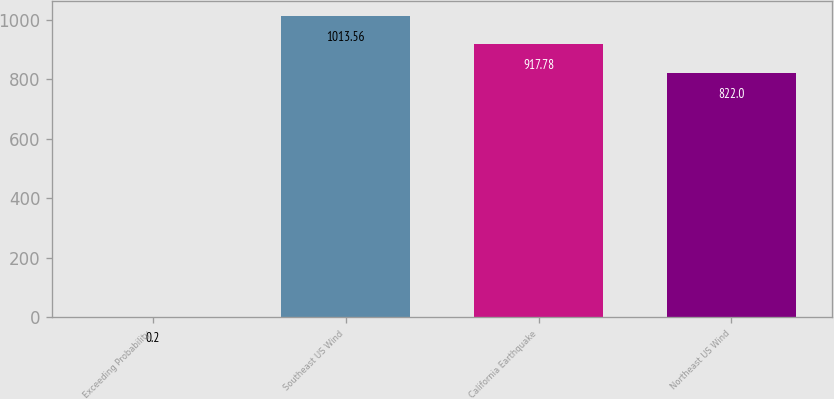<chart> <loc_0><loc_0><loc_500><loc_500><bar_chart><fcel>Exceeding Probability<fcel>Southeast US Wind<fcel>California Earthquake<fcel>Northeast US Wind<nl><fcel>0.2<fcel>1013.56<fcel>917.78<fcel>822<nl></chart> 